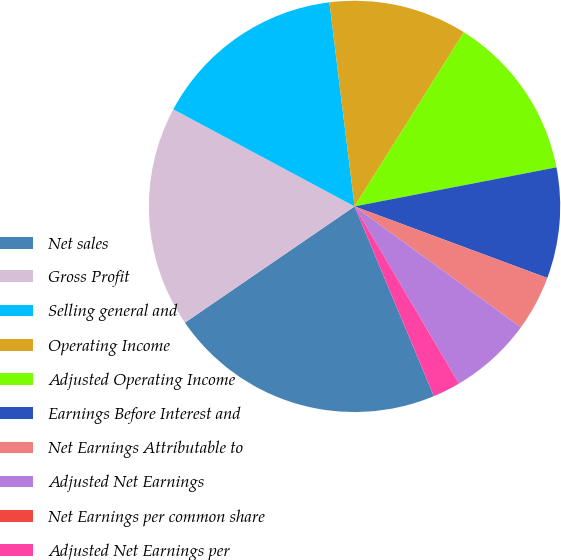Convert chart. <chart><loc_0><loc_0><loc_500><loc_500><pie_chart><fcel>Net sales<fcel>Gross Profit<fcel>Selling general and<fcel>Operating Income<fcel>Adjusted Operating Income<fcel>Earnings Before Interest and<fcel>Net Earnings Attributable to<fcel>Adjusted Net Earnings<fcel>Net Earnings per common share<fcel>Adjusted Net Earnings per<nl><fcel>21.74%<fcel>17.39%<fcel>15.22%<fcel>10.87%<fcel>13.04%<fcel>8.7%<fcel>4.35%<fcel>6.52%<fcel>0.0%<fcel>2.17%<nl></chart> 